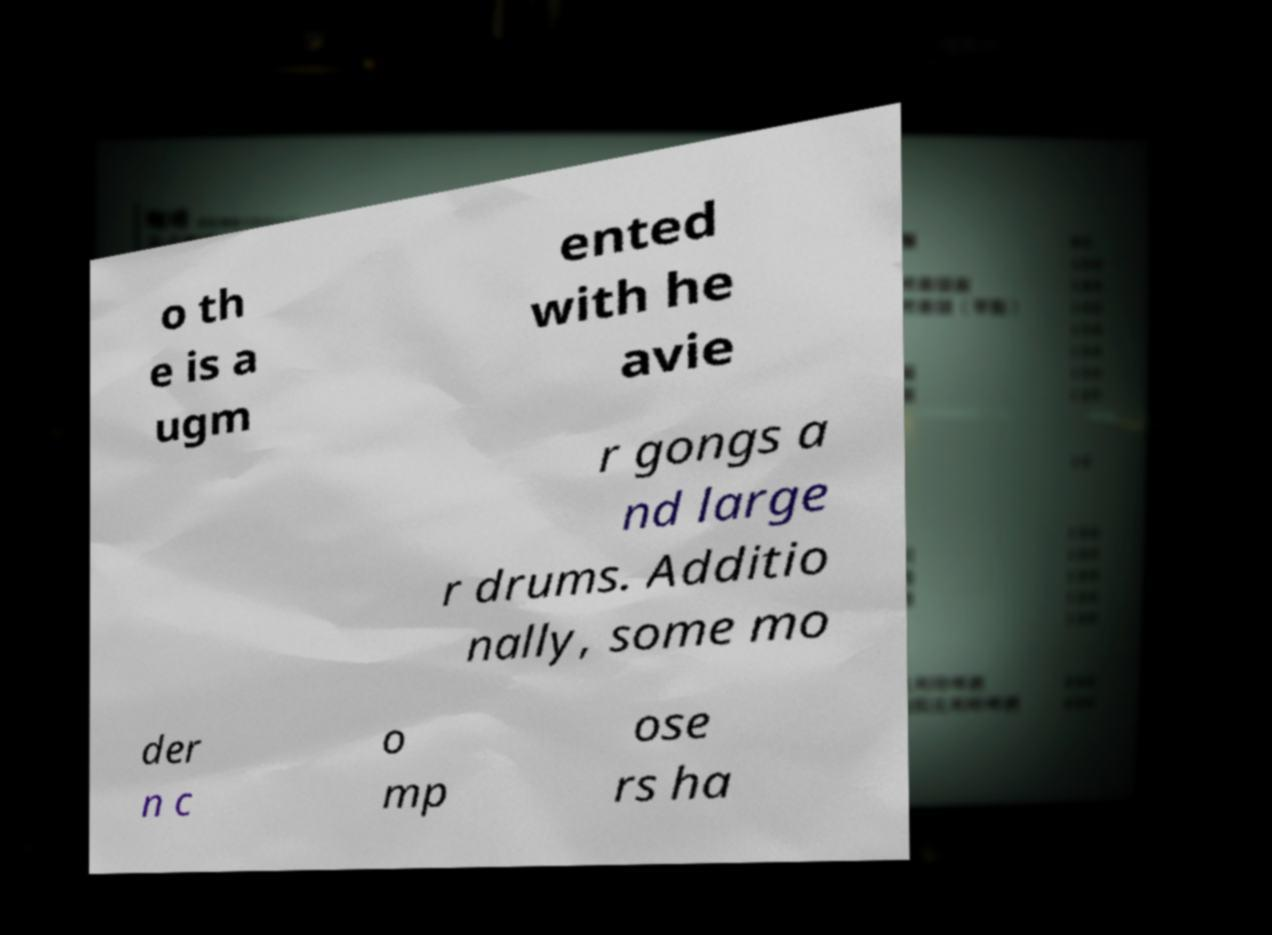Could you assist in decoding the text presented in this image and type it out clearly? o th e is a ugm ented with he avie r gongs a nd large r drums. Additio nally, some mo der n c o mp ose rs ha 